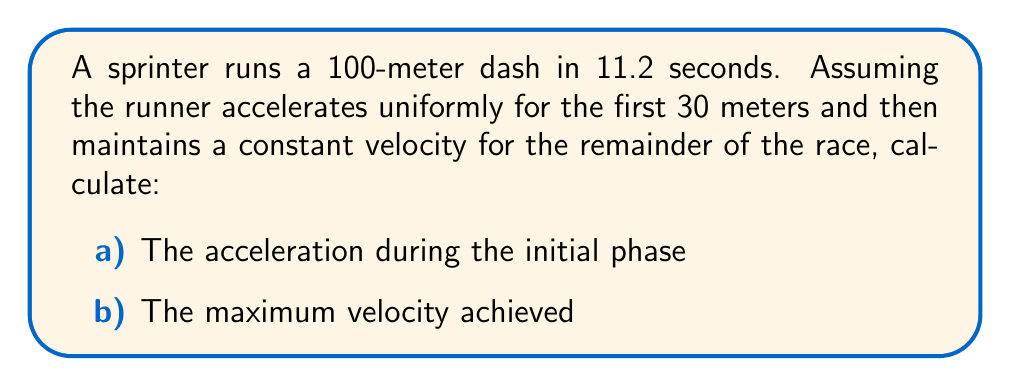What is the answer to this math problem? Let's approach this problem step by step:

1) First, we need to determine the time spent in the acceleration phase. Let's call this time $t_a$.

2) The total distance is 100 m, and the total time is 11.2 s. We can split this into two phases:
   - Acceleration phase: 0 to 30 m
   - Constant velocity phase: 30 to 100 m

3) For uniform acceleration, we can use the equation:
   $$ s = \frac{1}{2}at^2 $$
   where $s$ is distance, $a$ is acceleration, and $t$ is time.

4) For the constant velocity phase, we use:
   $$ s = vt $$
   where $v$ is the constant velocity (which is also the maximum velocity).

5) We can set up two equations:
   $$ 30 = \frac{1}{2}at_a^2 \quad \text{(acceleration phase)} $$
   $$ 70 = v(11.2 - t_a) \quad \text{(constant velocity phase)} $$

6) From the first equation:
   $$ v = at_a $$

7) Substituting this into the second equation:
   $$ 70 = at_a(11.2 - t_a) $$

8) Combining with the first equation:
   $$ 70 = \frac{60}{t_a}(11.2 - t_a) $$

9) Solving this equation (you can use a quadratic solver), we get:
   $$ t_a \approx 3.74 \text{ s} $$

10) Now we can calculate the acceleration:
    $$ a = \frac{2 \times 30}{t_a^2} = \frac{60}{3.74^2} \approx 4.29 \text{ m/s}^2 $$

11) And the maximum velocity:
    $$ v = at_a = 4.29 \times 3.74 \approx 16.04 \text{ m/s} $$
Answer: a) Acceleration: $4.29 \text{ m/s}^2$
b) Maximum velocity: $16.04 \text{ m/s}$ 